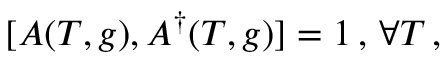Convert formula to latex. <formula><loc_0><loc_0><loc_500><loc_500>[ A ( T , g ) , A ^ { \dag } ( T , g ) ] = 1 \, , \, \forall T \, ,</formula> 